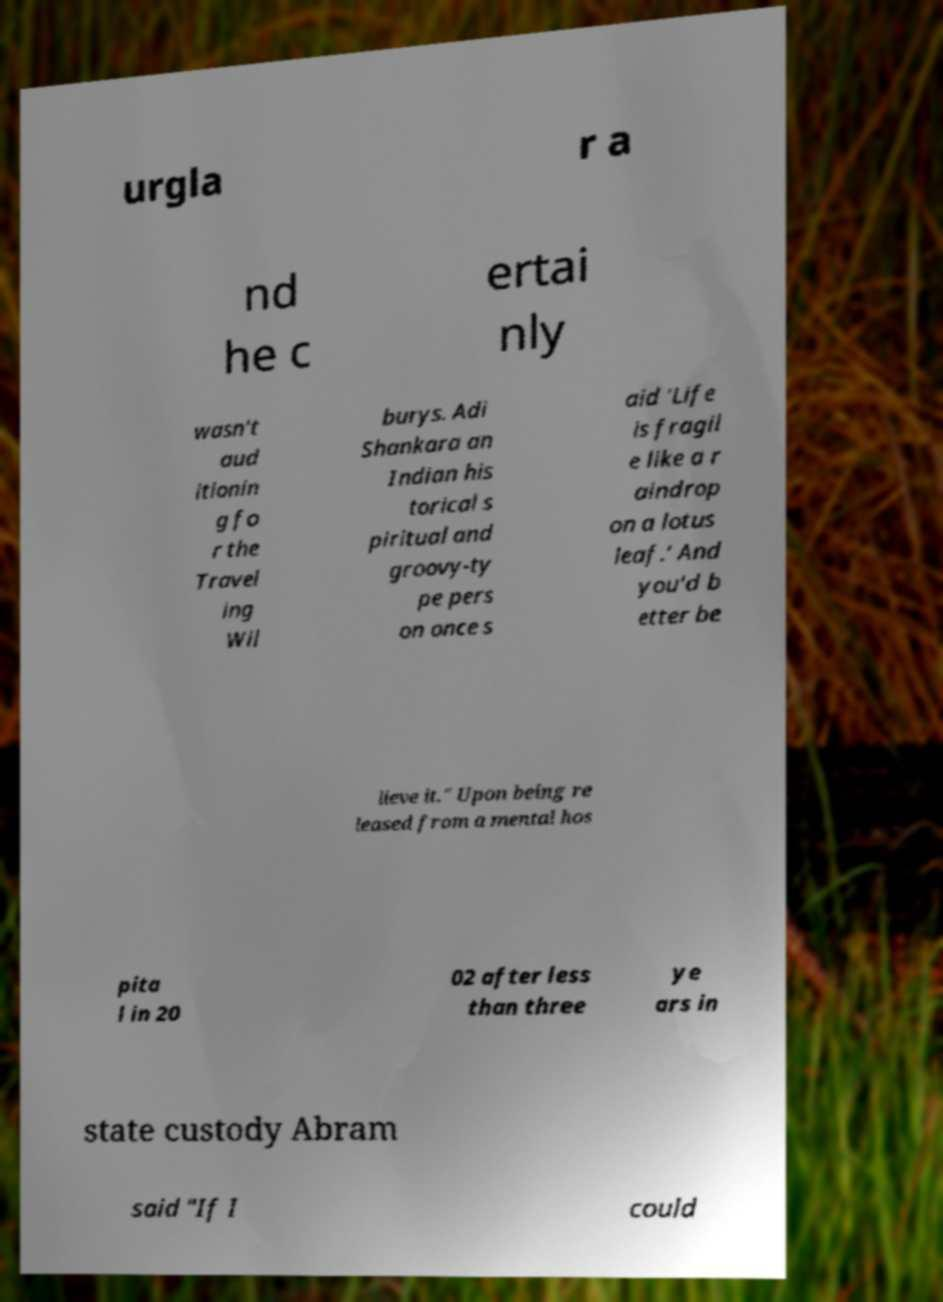Can you accurately transcribe the text from the provided image for me? urgla r a nd he c ertai nly wasn't aud itionin g fo r the Travel ing Wil burys. Adi Shankara an Indian his torical s piritual and groovy-ty pe pers on once s aid 'Life is fragil e like a r aindrop on a lotus leaf.' And you'd b etter be lieve it." Upon being re leased from a mental hos pita l in 20 02 after less than three ye ars in state custody Abram said "If I could 